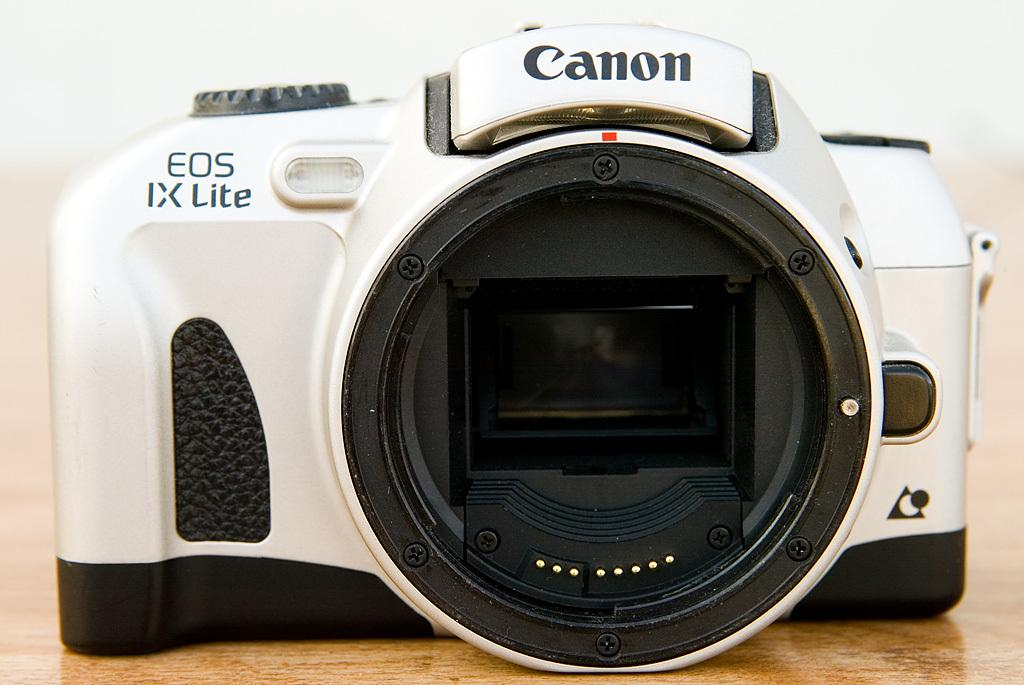<image>
Write a terse but informative summary of the picture. A white Canon camera with no lens on. 